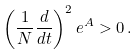Convert formula to latex. <formula><loc_0><loc_0><loc_500><loc_500>\left ( \frac { 1 } { N } \frac { d } { d t } \right ) ^ { 2 } e ^ { A } > 0 \, .</formula> 